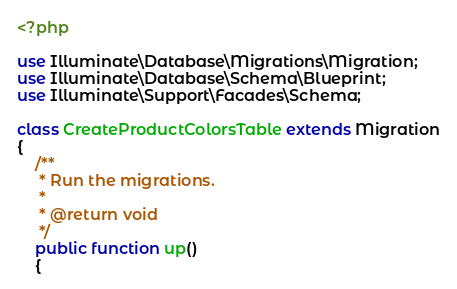<code> <loc_0><loc_0><loc_500><loc_500><_PHP_><?php

use Illuminate\Database\Migrations\Migration;
use Illuminate\Database\Schema\Blueprint;
use Illuminate\Support\Facades\Schema;

class CreateProductColorsTable extends Migration
{
    /**
     * Run the migrations.
     *
     * @return void
     */
    public function up()
    {</code> 